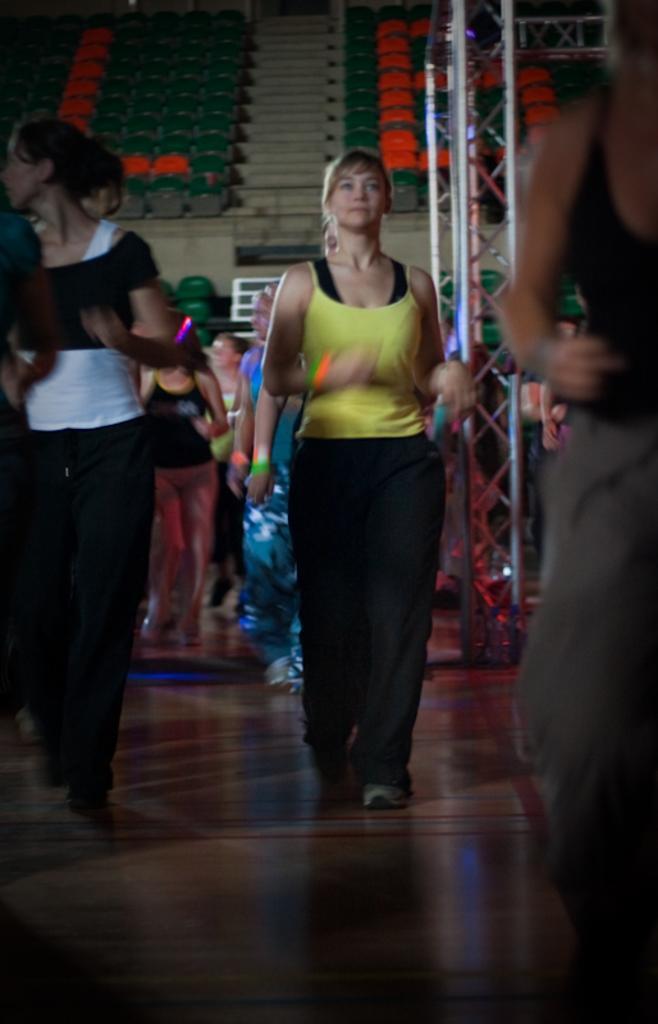Can you describe this image briefly? In this picture we can see some people walking here, in the background there are some chairs and stairs here, we can see rod here, at the bottom there is floor. 